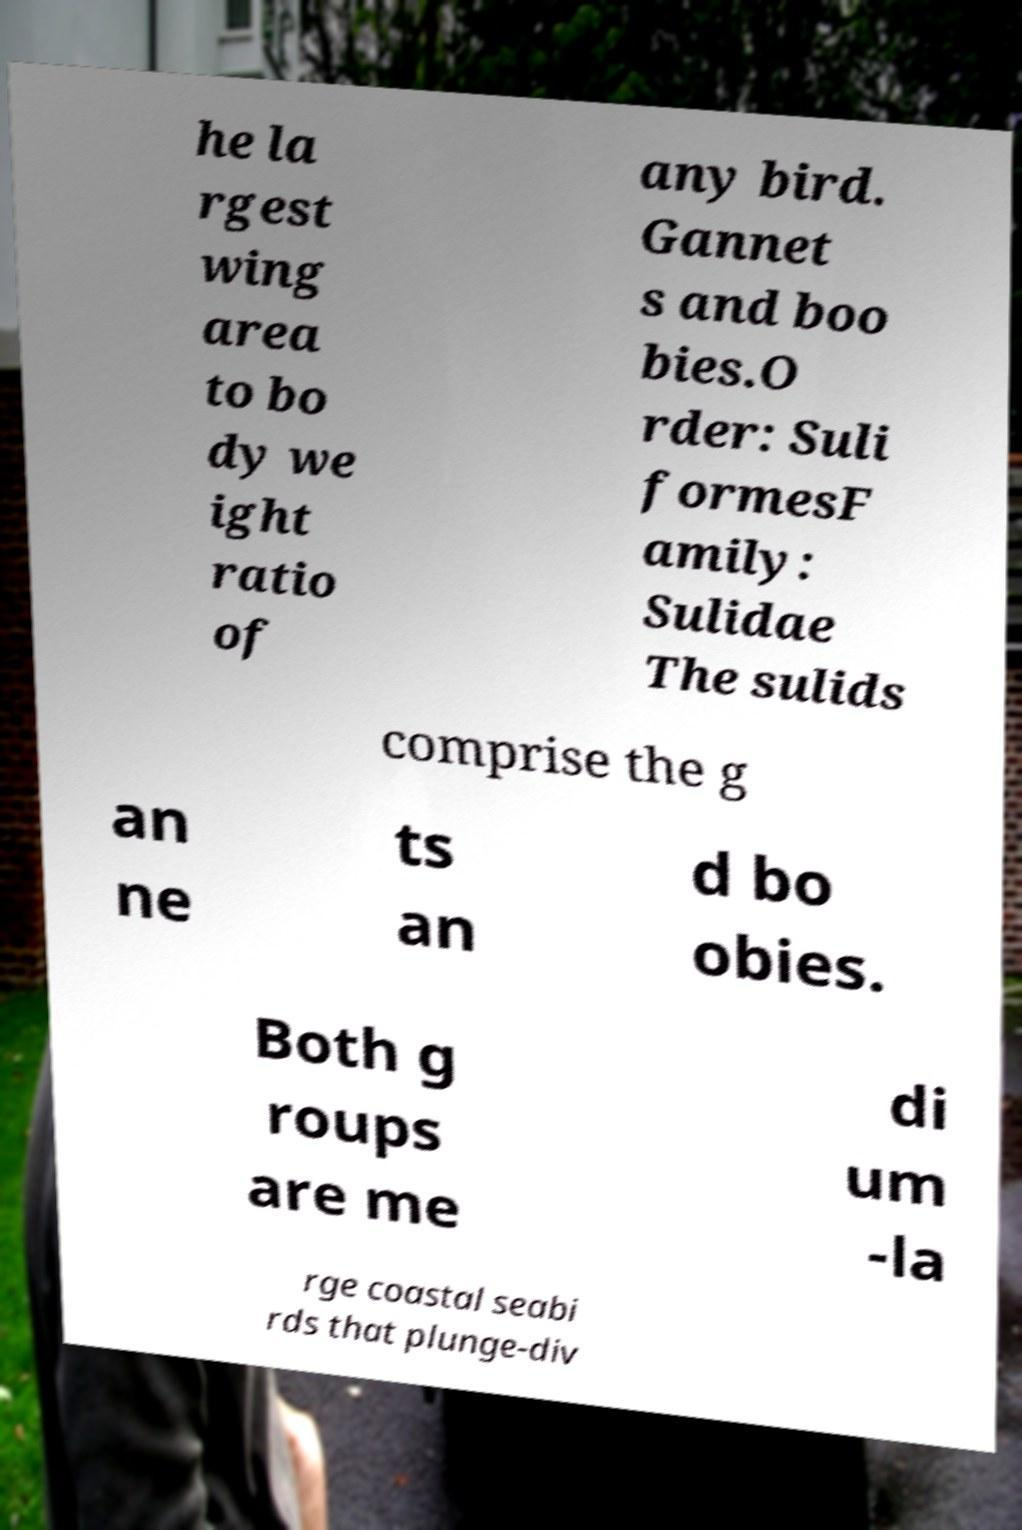Can you accurately transcribe the text from the provided image for me? he la rgest wing area to bo dy we ight ratio of any bird. Gannet s and boo bies.O rder: Suli formesF amily: Sulidae The sulids comprise the g an ne ts an d bo obies. Both g roups are me di um -la rge coastal seabi rds that plunge-div 